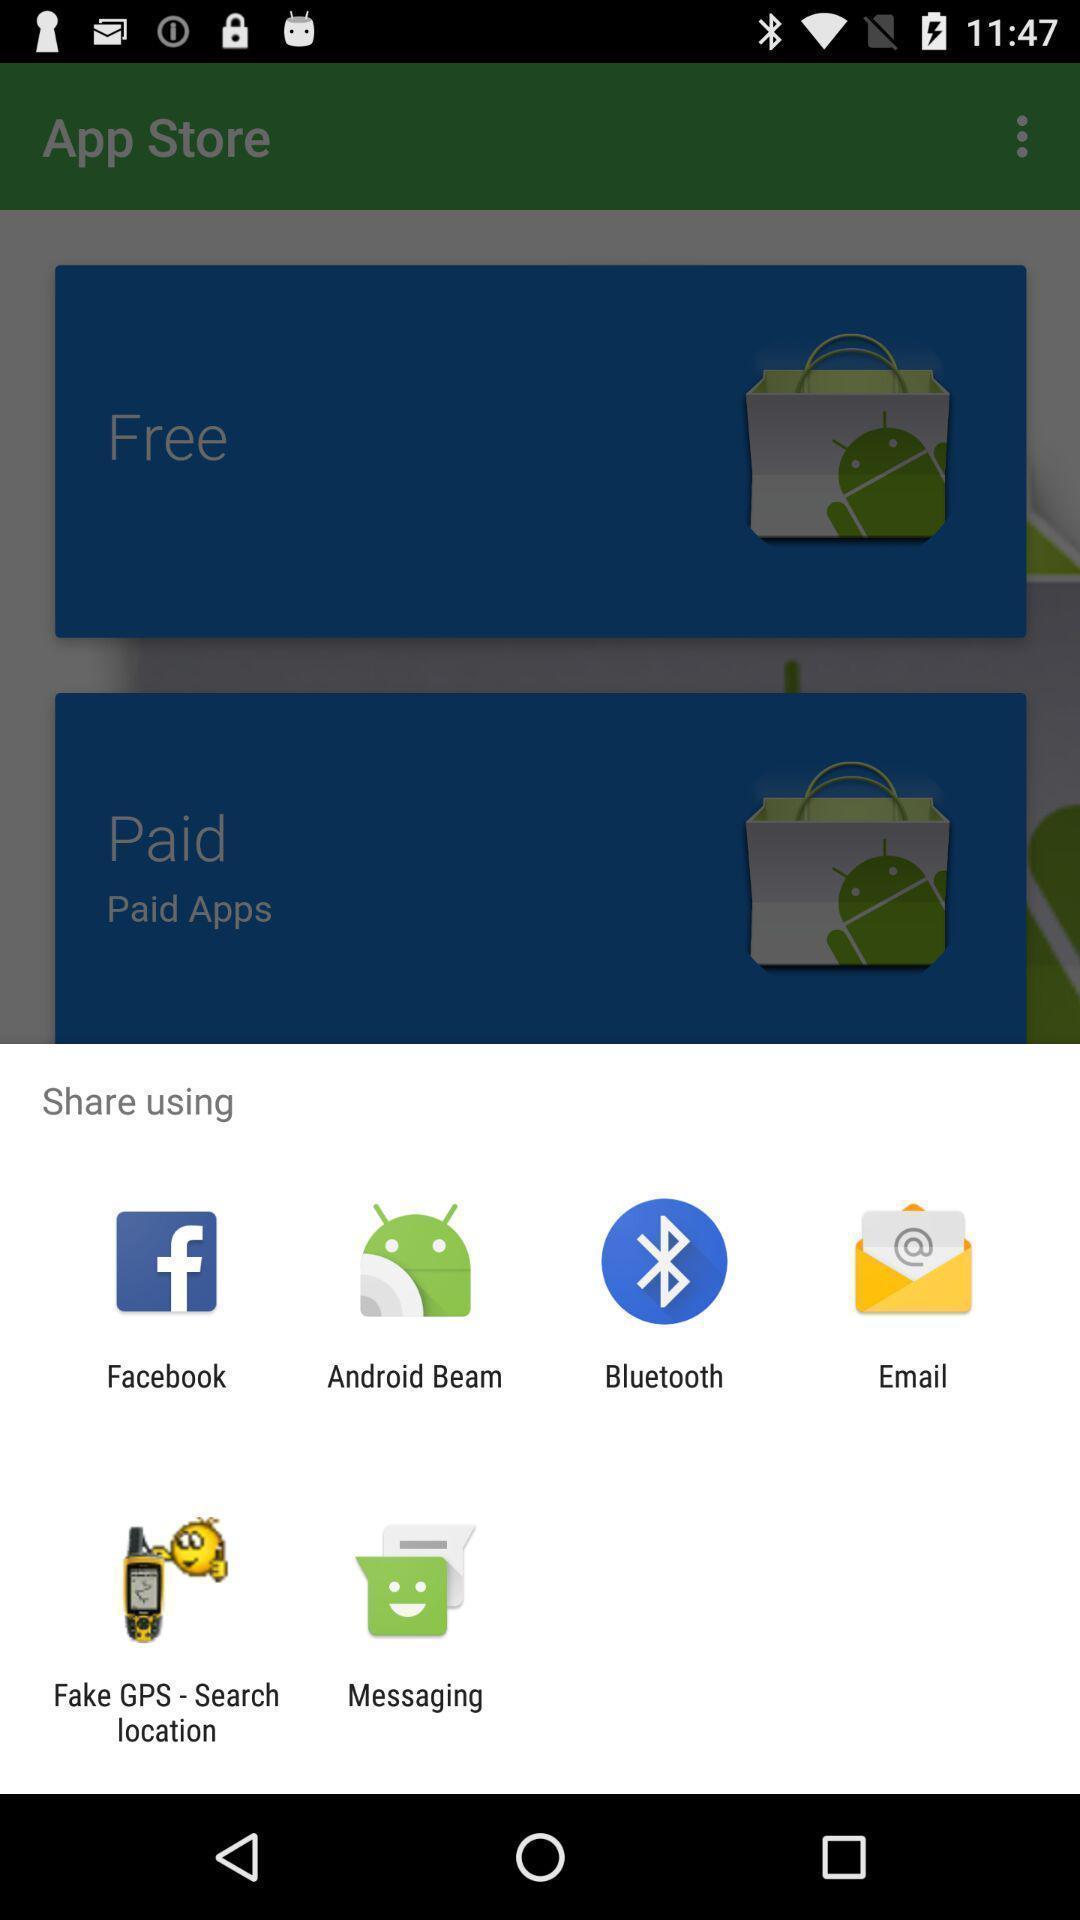What is the overall content of this screenshot? Push up page showing to choose preference app. 